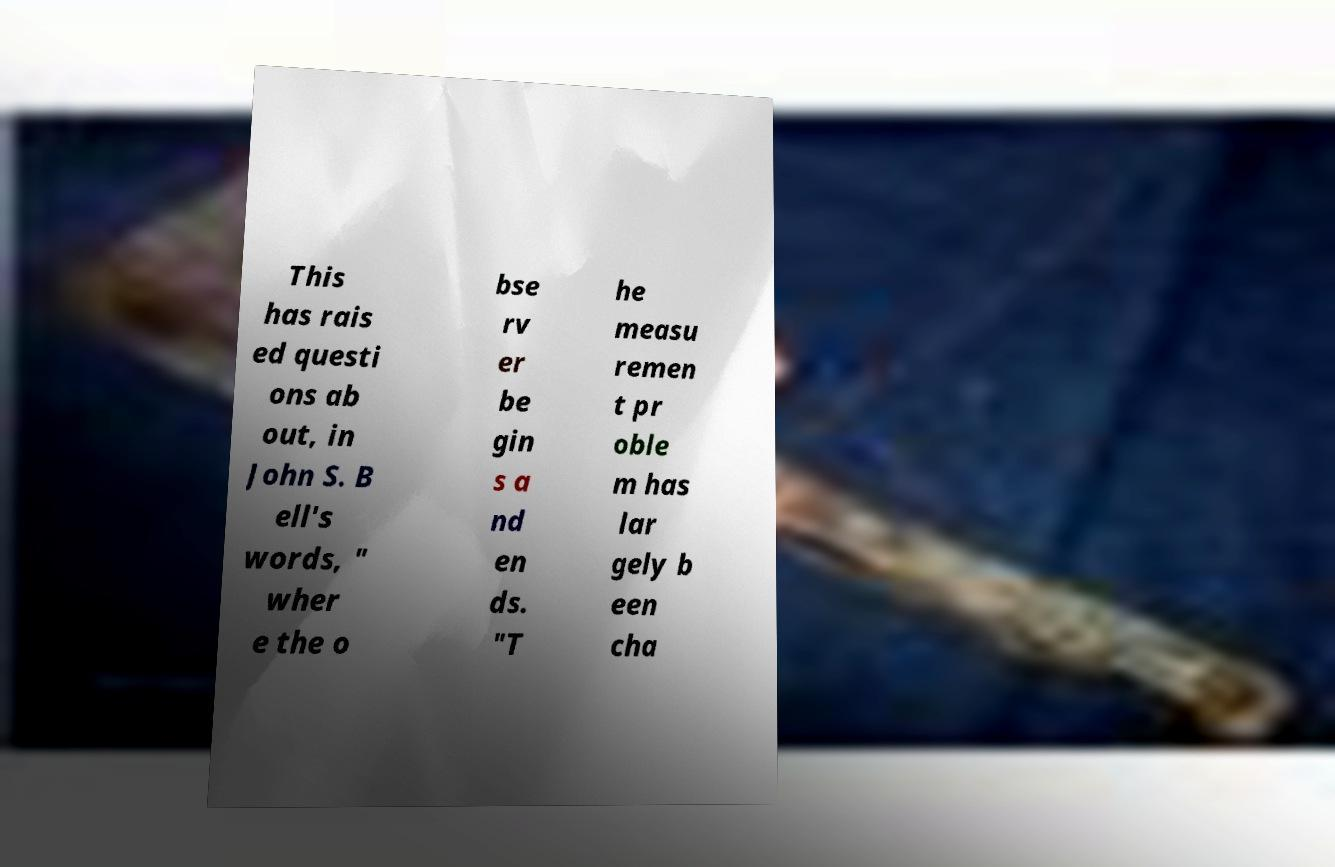Could you assist in decoding the text presented in this image and type it out clearly? This has rais ed questi ons ab out, in John S. B ell's words, " wher e the o bse rv er be gin s a nd en ds. "T he measu remen t pr oble m has lar gely b een cha 